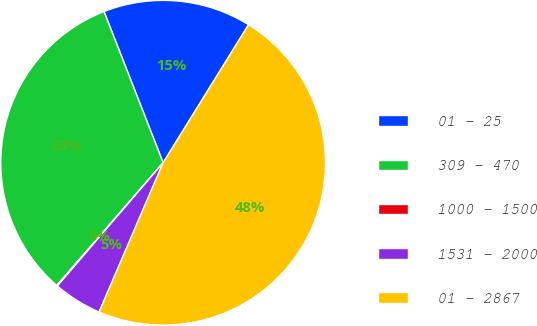<chart> <loc_0><loc_0><loc_500><loc_500><pie_chart><fcel>01 - 25<fcel>309 - 470<fcel>1000 - 1500<fcel>1531 - 2000<fcel>01 - 2867<nl><fcel>14.75%<fcel>32.7%<fcel>0.08%<fcel>4.84%<fcel>47.63%<nl></chart> 